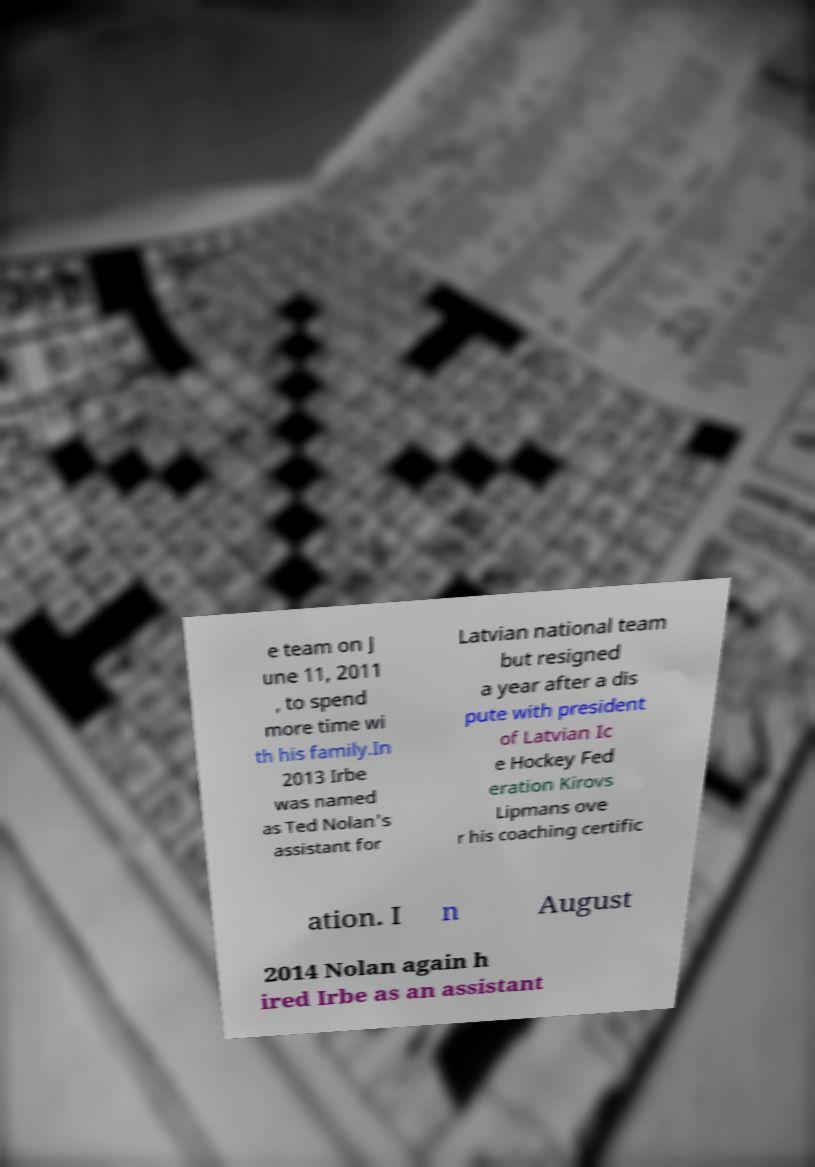Could you assist in decoding the text presented in this image and type it out clearly? e team on J une 11, 2011 , to spend more time wi th his family.In 2013 Irbe was named as Ted Nolan's assistant for Latvian national team but resigned a year after a dis pute with president of Latvian Ic e Hockey Fed eration Kirovs Lipmans ove r his coaching certific ation. I n August 2014 Nolan again h ired Irbe as an assistant 